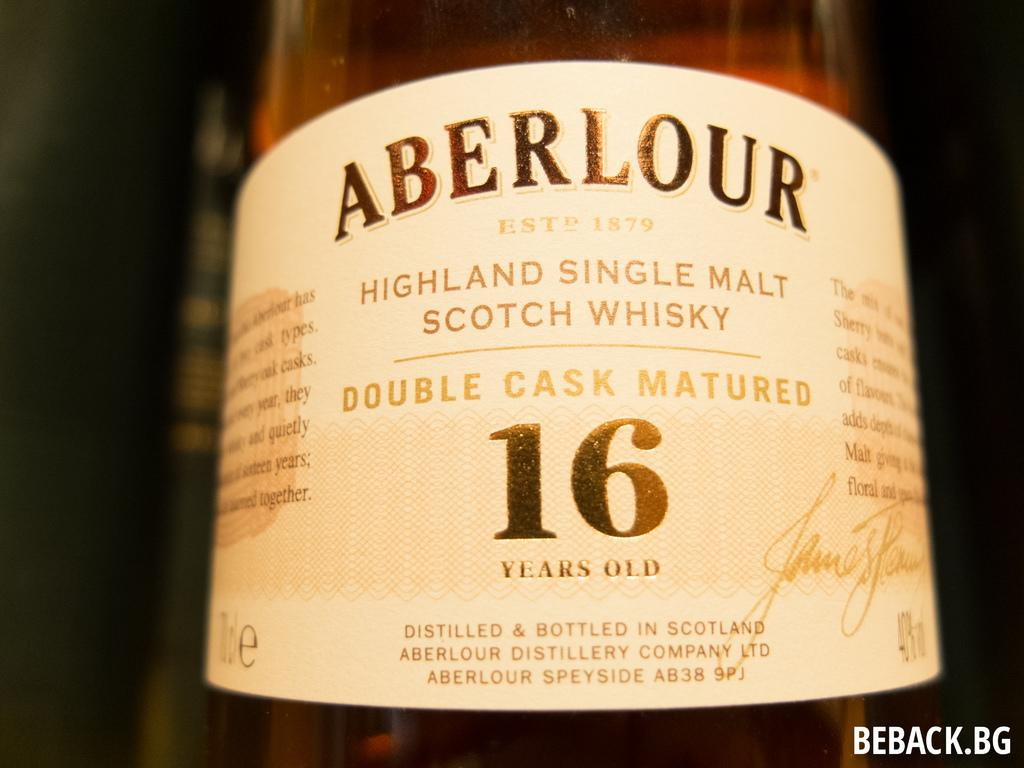<image>
Relay a brief, clear account of the picture shown. A label from a 16 year old Scotch whiskey. 